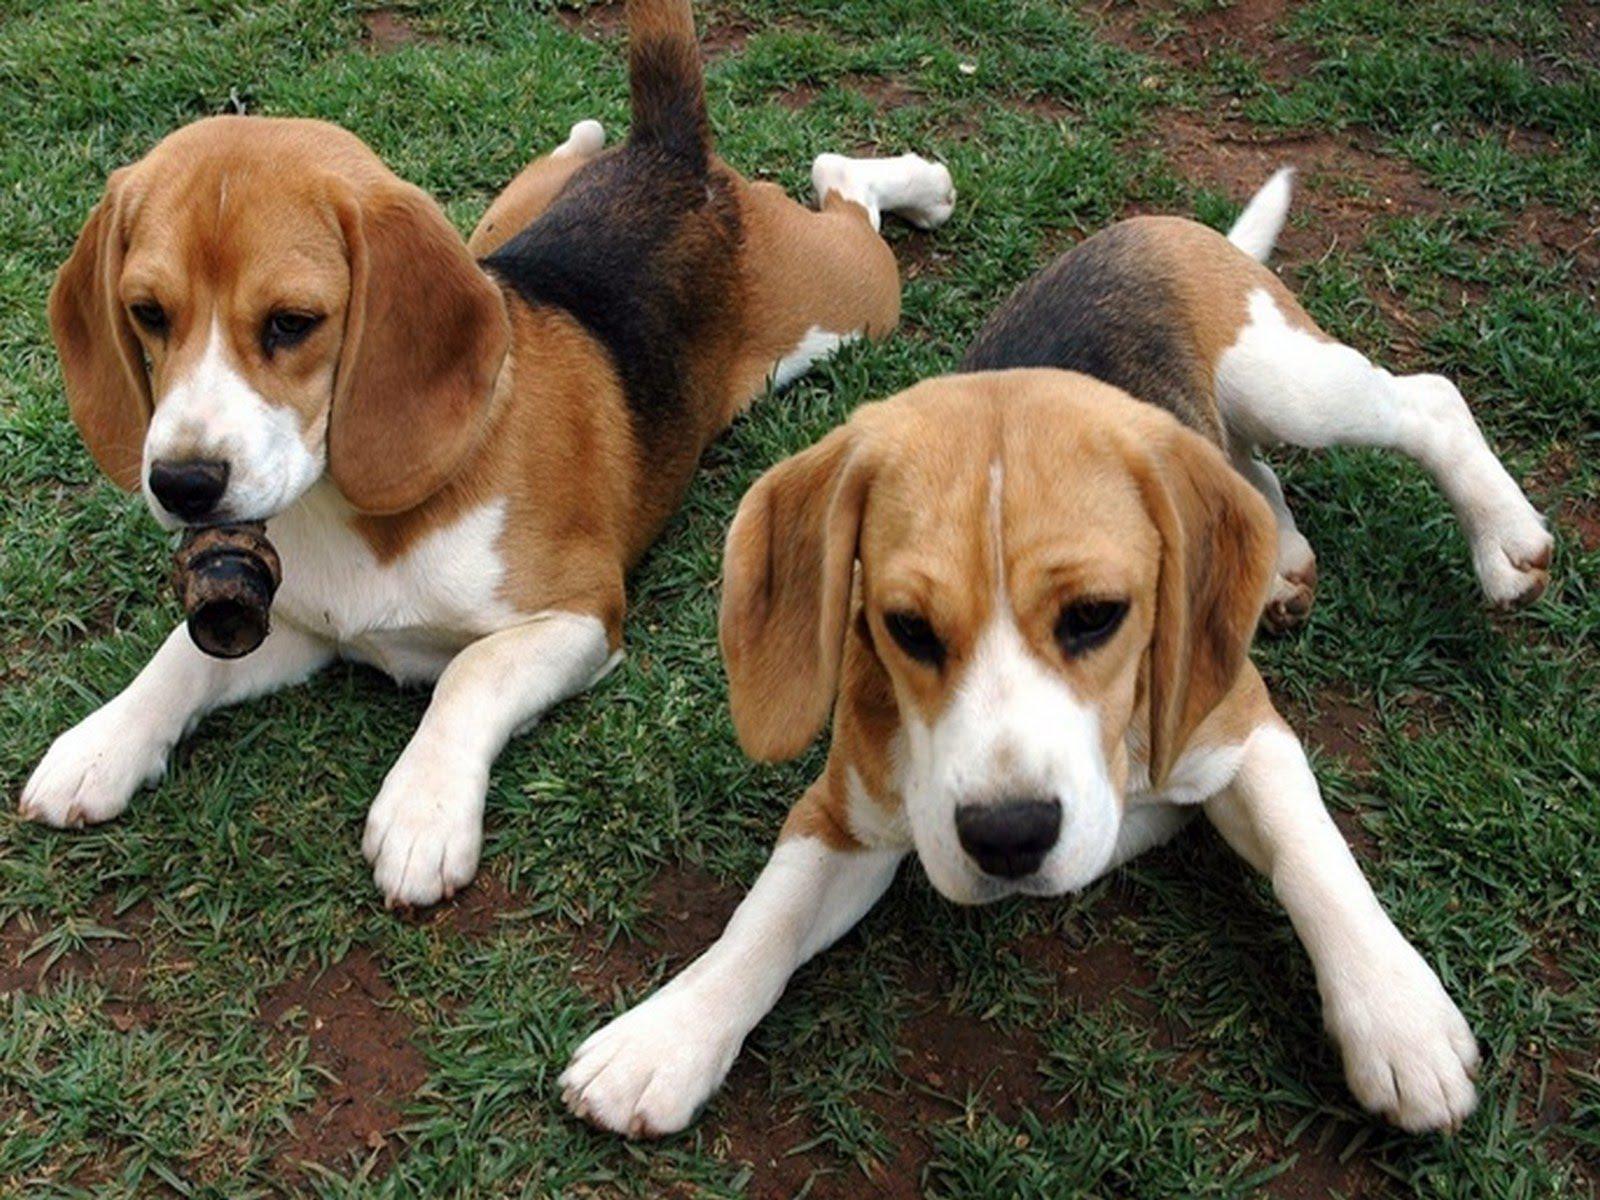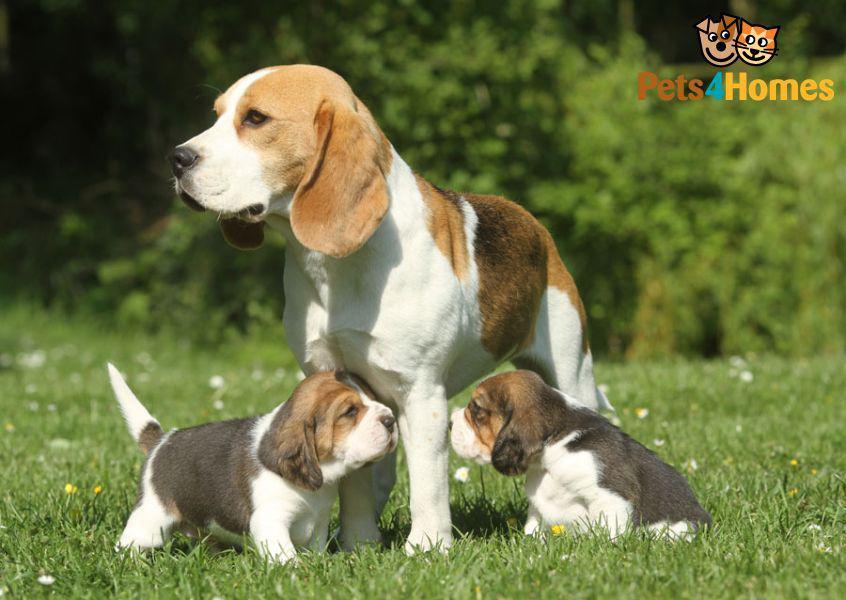The first image is the image on the left, the second image is the image on the right. Given the left and right images, does the statement "A single dog is standing on all fours in the image on the left." hold true? Answer yes or no. No. The first image is the image on the left, the second image is the image on the right. For the images displayed, is the sentence "Each image contains exactly one beagle, and each dog is in approximately the same pose." factually correct? Answer yes or no. No. 